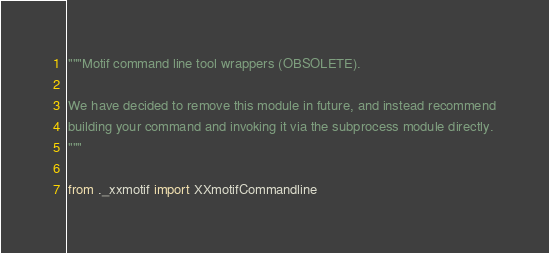Convert code to text. <code><loc_0><loc_0><loc_500><loc_500><_Python_>
"""Motif command line tool wrappers (OBSOLETE).

We have decided to remove this module in future, and instead recommend
building your command and invoking it via the subprocess module directly.
"""

from ._xxmotif import XXmotifCommandline
</code> 